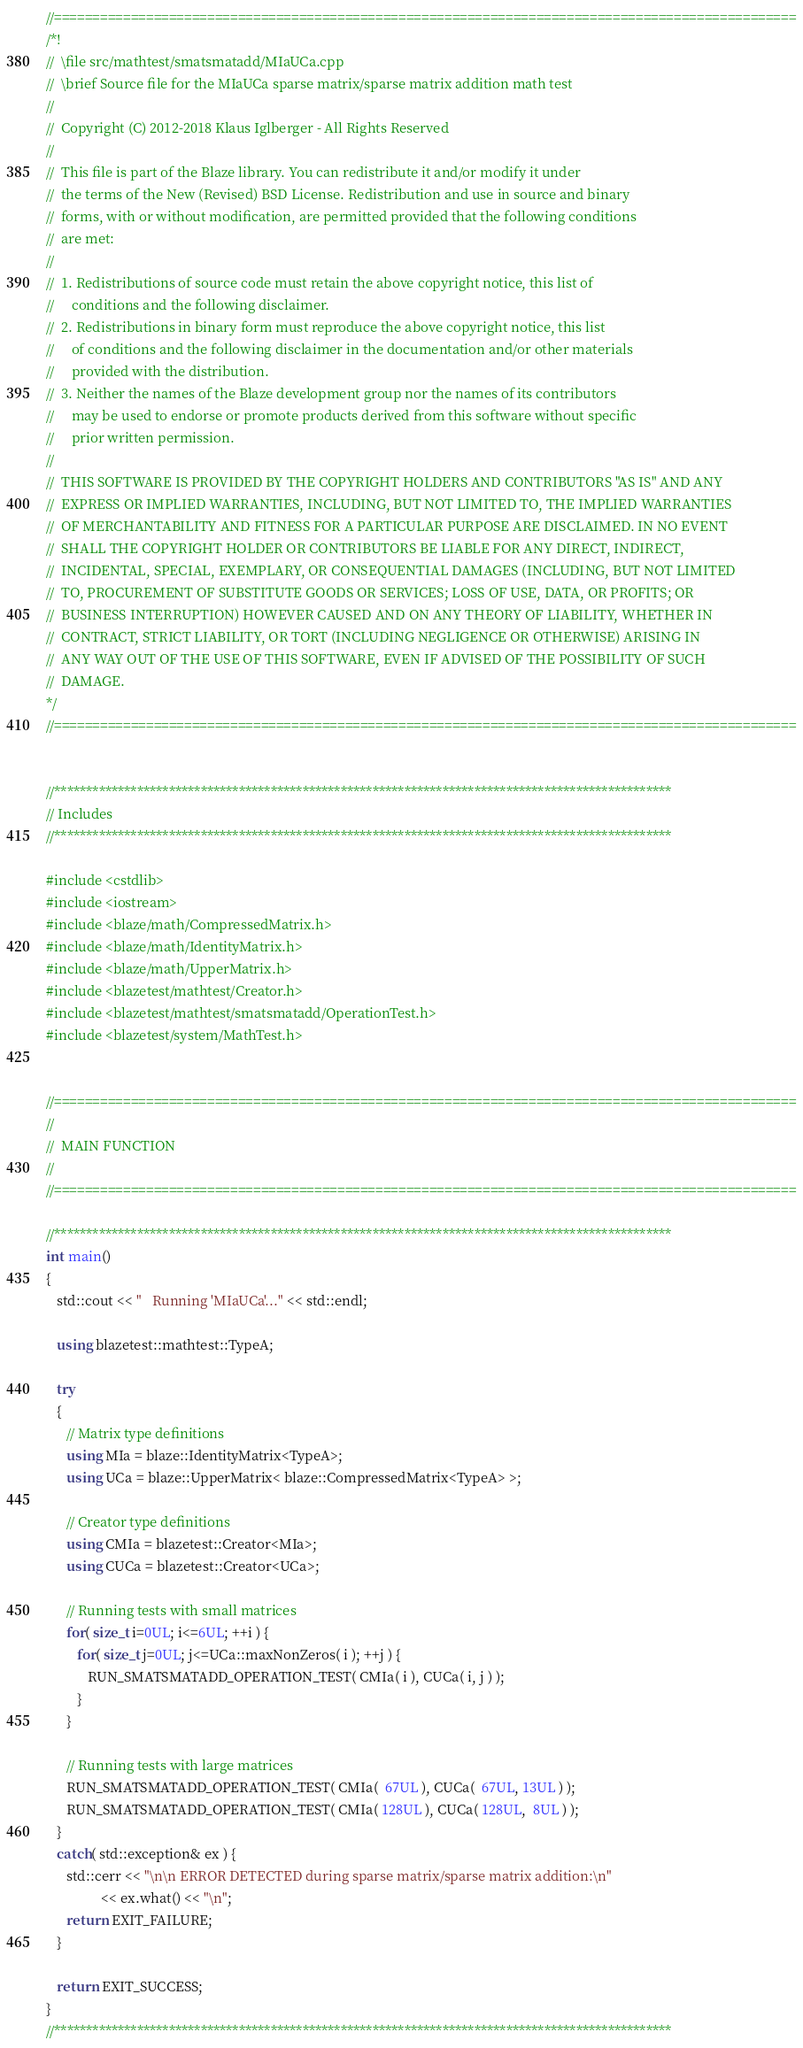Convert code to text. <code><loc_0><loc_0><loc_500><loc_500><_C++_>//=================================================================================================
/*!
//  \file src/mathtest/smatsmatadd/MIaUCa.cpp
//  \brief Source file for the MIaUCa sparse matrix/sparse matrix addition math test
//
//  Copyright (C) 2012-2018 Klaus Iglberger - All Rights Reserved
//
//  This file is part of the Blaze library. You can redistribute it and/or modify it under
//  the terms of the New (Revised) BSD License. Redistribution and use in source and binary
//  forms, with or without modification, are permitted provided that the following conditions
//  are met:
//
//  1. Redistributions of source code must retain the above copyright notice, this list of
//     conditions and the following disclaimer.
//  2. Redistributions in binary form must reproduce the above copyright notice, this list
//     of conditions and the following disclaimer in the documentation and/or other materials
//     provided with the distribution.
//  3. Neither the names of the Blaze development group nor the names of its contributors
//     may be used to endorse or promote products derived from this software without specific
//     prior written permission.
//
//  THIS SOFTWARE IS PROVIDED BY THE COPYRIGHT HOLDERS AND CONTRIBUTORS "AS IS" AND ANY
//  EXPRESS OR IMPLIED WARRANTIES, INCLUDING, BUT NOT LIMITED TO, THE IMPLIED WARRANTIES
//  OF MERCHANTABILITY AND FITNESS FOR A PARTICULAR PURPOSE ARE DISCLAIMED. IN NO EVENT
//  SHALL THE COPYRIGHT HOLDER OR CONTRIBUTORS BE LIABLE FOR ANY DIRECT, INDIRECT,
//  INCIDENTAL, SPECIAL, EXEMPLARY, OR CONSEQUENTIAL DAMAGES (INCLUDING, BUT NOT LIMITED
//  TO, PROCUREMENT OF SUBSTITUTE GOODS OR SERVICES; LOSS OF USE, DATA, OR PROFITS; OR
//  BUSINESS INTERRUPTION) HOWEVER CAUSED AND ON ANY THEORY OF LIABILITY, WHETHER IN
//  CONTRACT, STRICT LIABILITY, OR TORT (INCLUDING NEGLIGENCE OR OTHERWISE) ARISING IN
//  ANY WAY OUT OF THE USE OF THIS SOFTWARE, EVEN IF ADVISED OF THE POSSIBILITY OF SUCH
//  DAMAGE.
*/
//=================================================================================================


//*************************************************************************************************
// Includes
//*************************************************************************************************

#include <cstdlib>
#include <iostream>
#include <blaze/math/CompressedMatrix.h>
#include <blaze/math/IdentityMatrix.h>
#include <blaze/math/UpperMatrix.h>
#include <blazetest/mathtest/Creator.h>
#include <blazetest/mathtest/smatsmatadd/OperationTest.h>
#include <blazetest/system/MathTest.h>


//=================================================================================================
//
//  MAIN FUNCTION
//
//=================================================================================================

//*************************************************************************************************
int main()
{
   std::cout << "   Running 'MIaUCa'..." << std::endl;

   using blazetest::mathtest::TypeA;

   try
   {
      // Matrix type definitions
      using MIa = blaze::IdentityMatrix<TypeA>;
      using UCa = blaze::UpperMatrix< blaze::CompressedMatrix<TypeA> >;

      // Creator type definitions
      using CMIa = blazetest::Creator<MIa>;
      using CUCa = blazetest::Creator<UCa>;

      // Running tests with small matrices
      for( size_t i=0UL; i<=6UL; ++i ) {
         for( size_t j=0UL; j<=UCa::maxNonZeros( i ); ++j ) {
            RUN_SMATSMATADD_OPERATION_TEST( CMIa( i ), CUCa( i, j ) );
         }
      }

      // Running tests with large matrices
      RUN_SMATSMATADD_OPERATION_TEST( CMIa(  67UL ), CUCa(  67UL, 13UL ) );
      RUN_SMATSMATADD_OPERATION_TEST( CMIa( 128UL ), CUCa( 128UL,  8UL ) );
   }
   catch( std::exception& ex ) {
      std::cerr << "\n\n ERROR DETECTED during sparse matrix/sparse matrix addition:\n"
                << ex.what() << "\n";
      return EXIT_FAILURE;
   }

   return EXIT_SUCCESS;
}
//*************************************************************************************************
</code> 